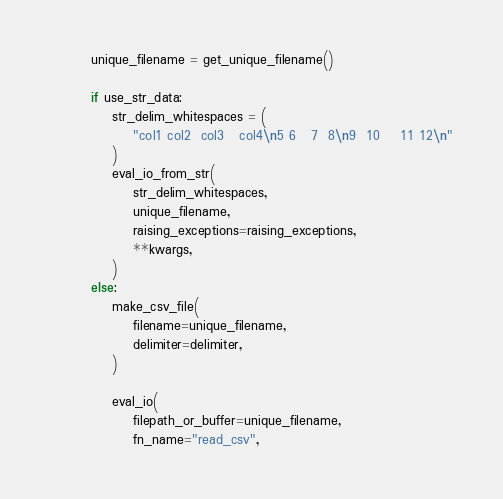Convert code to text. <code><loc_0><loc_0><loc_500><loc_500><_Python_>        unique_filename = get_unique_filename()

        if use_str_data:
            str_delim_whitespaces = (
                "col1 col2  col3   col4\n5 6   7  8\n9  10    11 12\n"
            )
            eval_io_from_str(
                str_delim_whitespaces,
                unique_filename,
                raising_exceptions=raising_exceptions,
                **kwargs,
            )
        else:
            make_csv_file(
                filename=unique_filename,
                delimiter=delimiter,
            )

            eval_io(
                filepath_or_buffer=unique_filename,
                fn_name="read_csv",</code> 